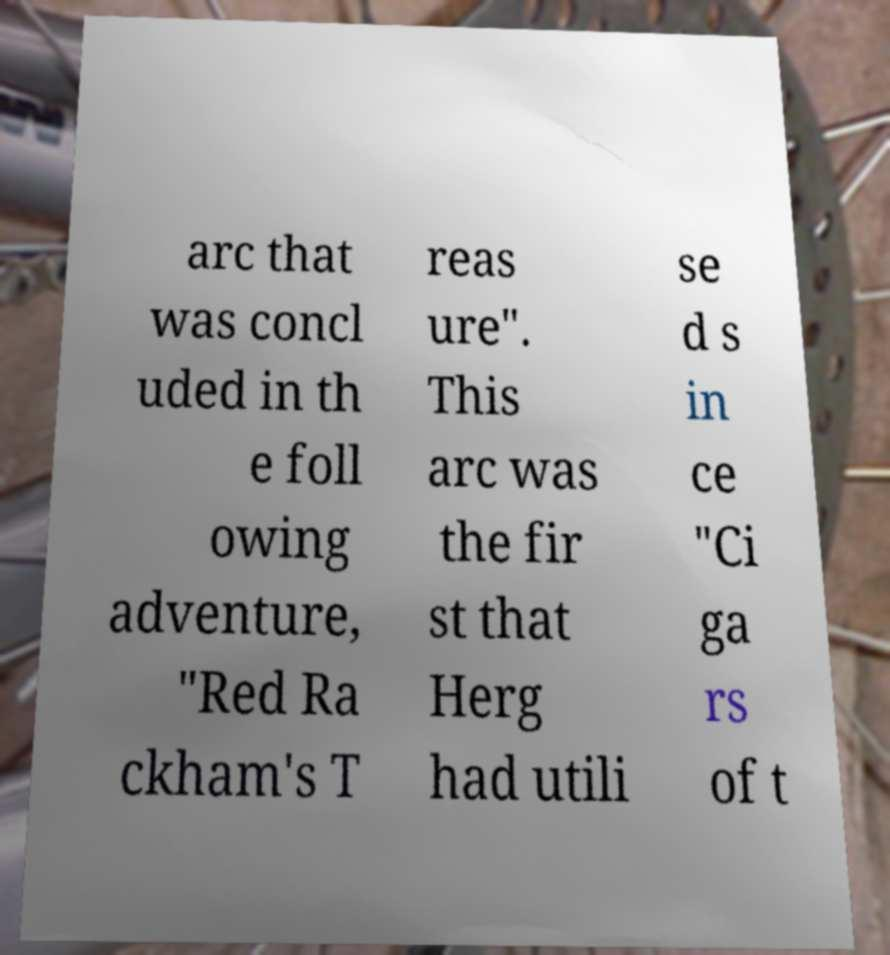Please identify and transcribe the text found in this image. arc that was concl uded in th e foll owing adventure, "Red Ra ckham's T reas ure". This arc was the fir st that Herg had utili se d s in ce "Ci ga rs of t 